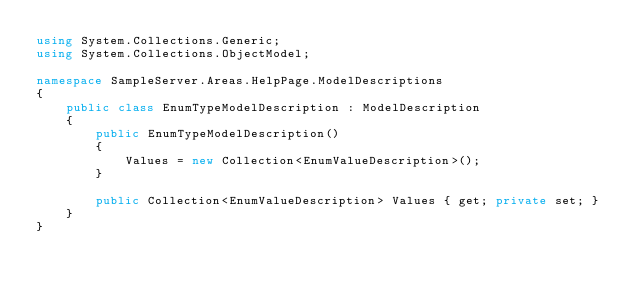<code> <loc_0><loc_0><loc_500><loc_500><_C#_>using System.Collections.Generic;
using System.Collections.ObjectModel;

namespace SampleServer.Areas.HelpPage.ModelDescriptions
{
    public class EnumTypeModelDescription : ModelDescription
    {
        public EnumTypeModelDescription()
        {
            Values = new Collection<EnumValueDescription>();
        }

        public Collection<EnumValueDescription> Values { get; private set; }
    }
}</code> 